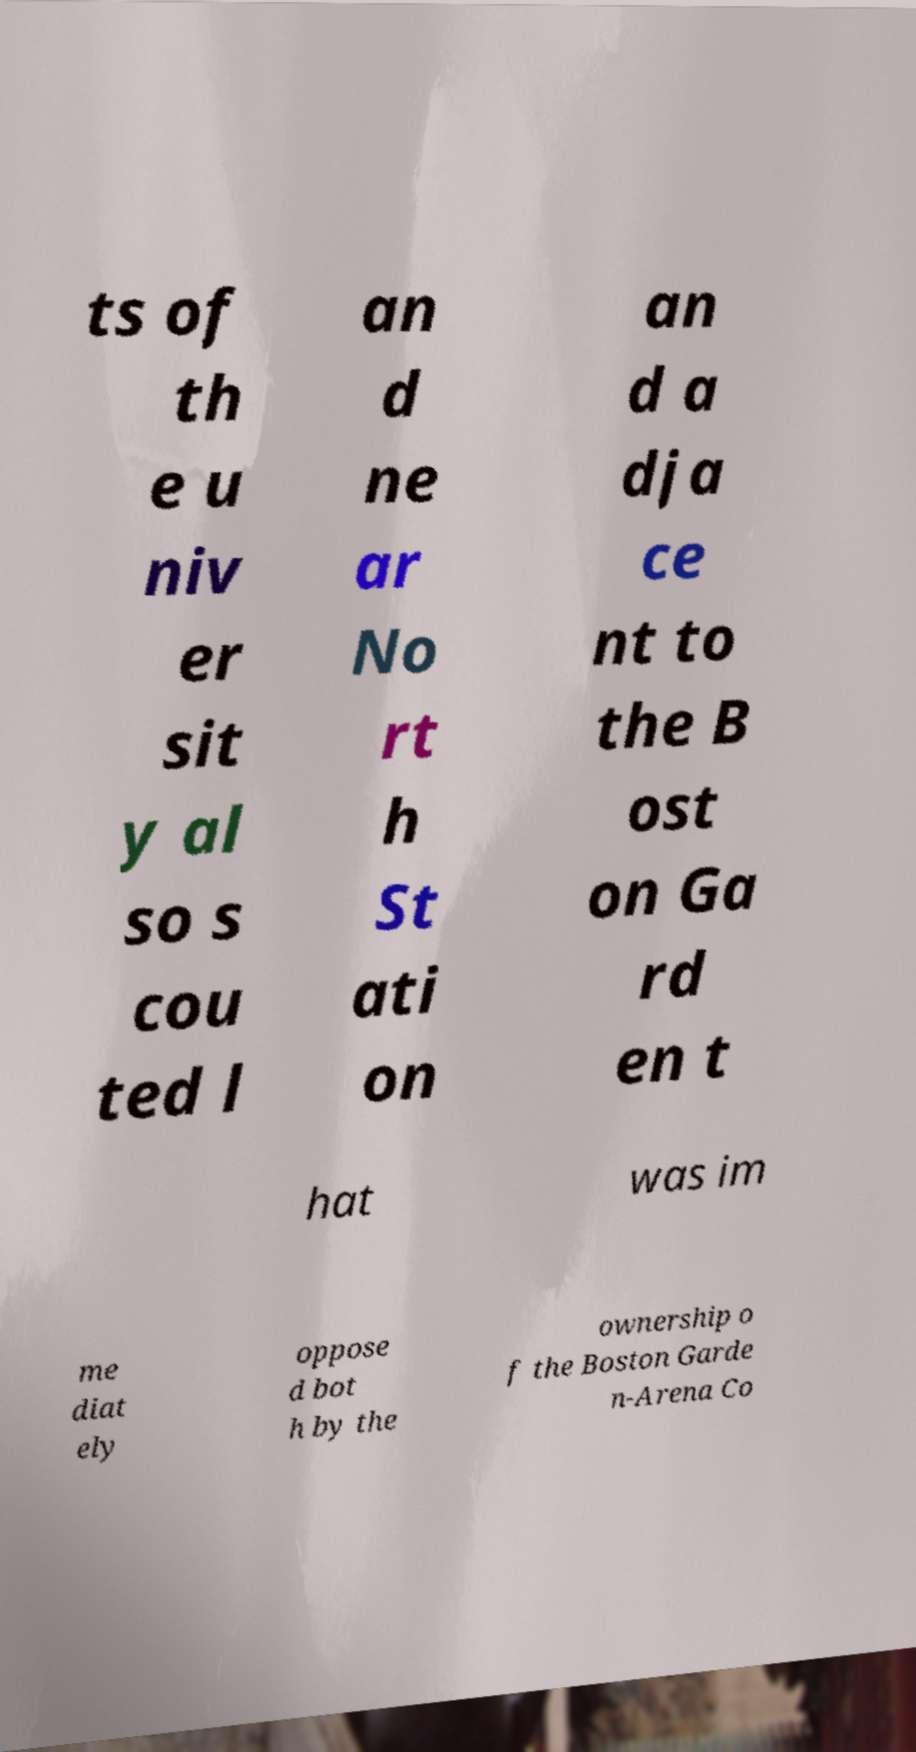Please identify and transcribe the text found in this image. ts of th e u niv er sit y al so s cou ted l an d ne ar No rt h St ati on an d a dja ce nt to the B ost on Ga rd en t hat was im me diat ely oppose d bot h by the ownership o f the Boston Garde n-Arena Co 